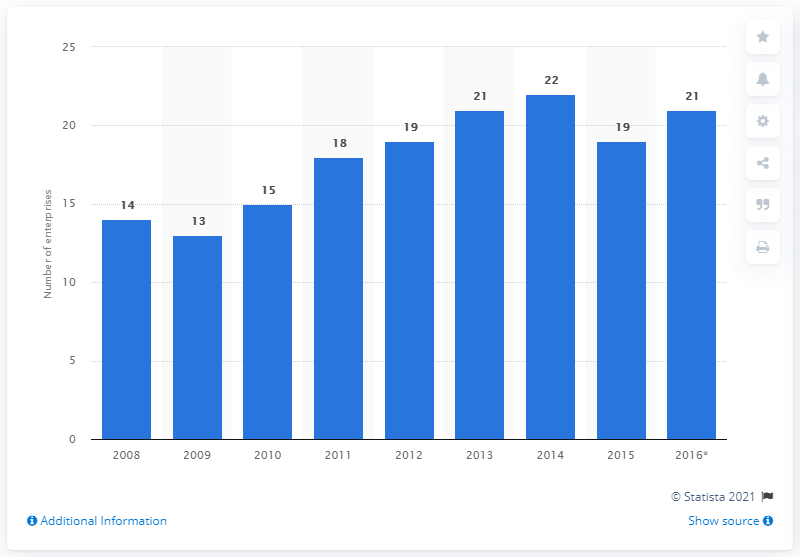Mention a couple of crucial points in this snapshot. In 2015, 19 enterprises in Slovenia manufactured pharmaceutical preparations. 